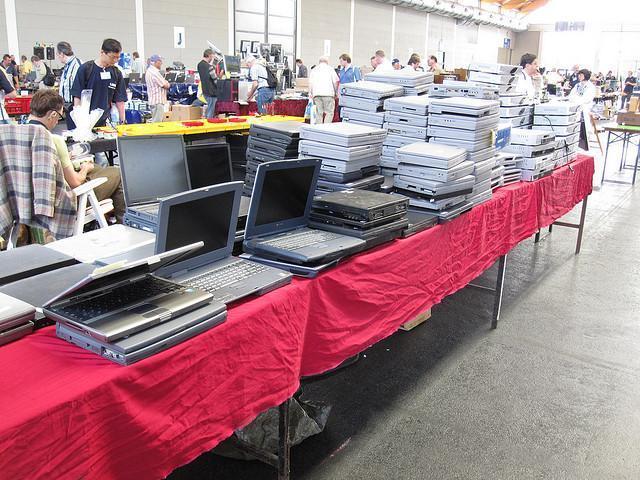How many laptops are visible?
Give a very brief answer. 7. How many people are in the picture?
Give a very brief answer. 3. 